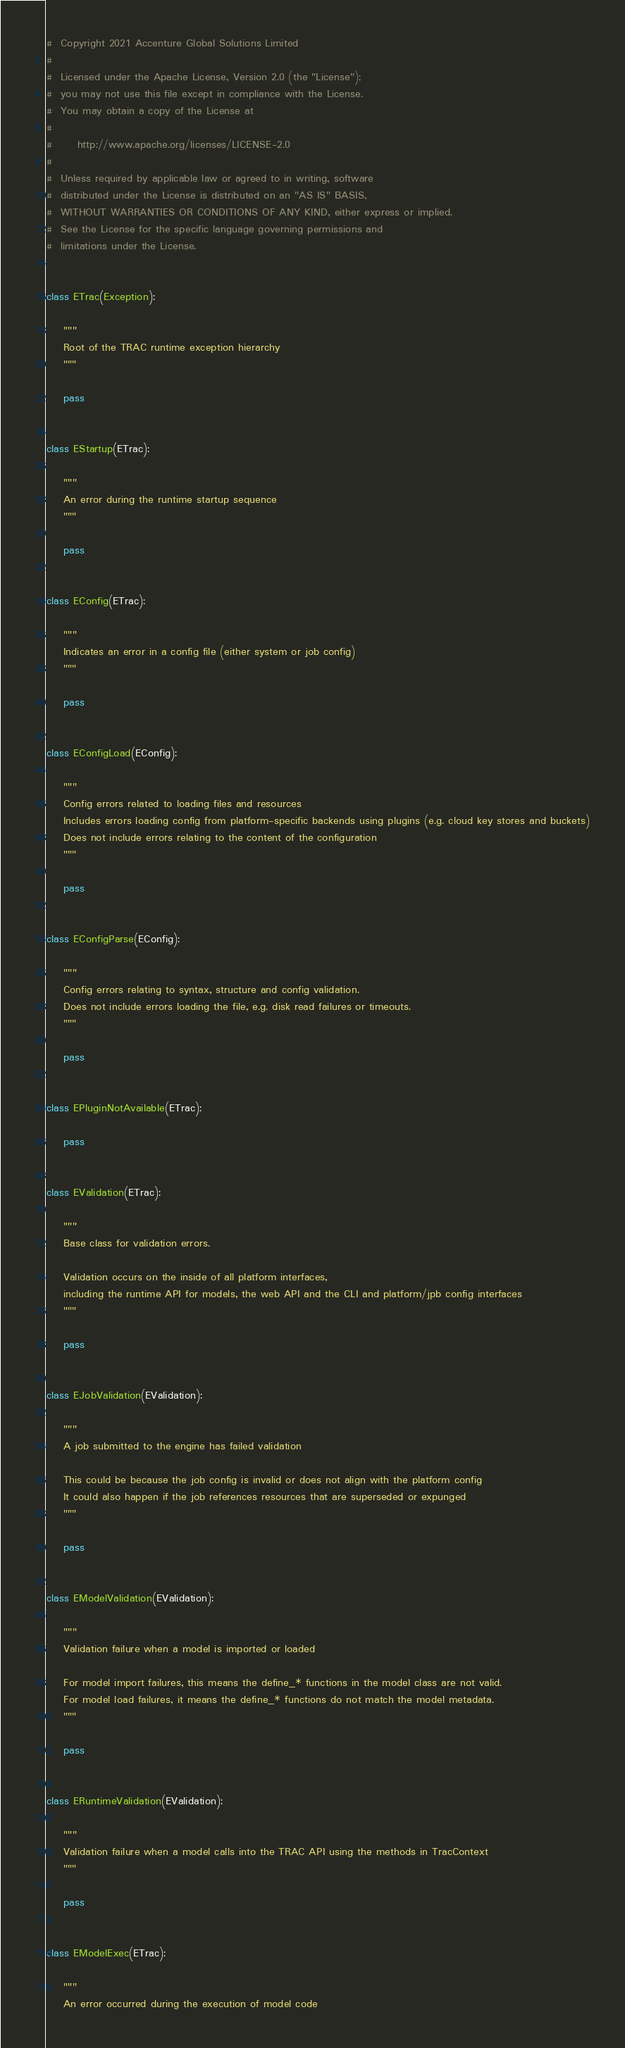<code> <loc_0><loc_0><loc_500><loc_500><_Python_>#  Copyright 2021 Accenture Global Solutions Limited
#
#  Licensed under the Apache License, Version 2.0 (the "License");
#  you may not use this file except in compliance with the License.
#  You may obtain a copy of the License at
#
#      http://www.apache.org/licenses/LICENSE-2.0
#
#  Unless required by applicable law or agreed to in writing, software
#  distributed under the License is distributed on an "AS IS" BASIS,
#  WITHOUT WARRANTIES OR CONDITIONS OF ANY KIND, either express or implied.
#  See the License for the specific language governing permissions and
#  limitations under the License.


class ETrac(Exception):

    """
    Root of the TRAC runtime exception hierarchy
    """

    pass


class EStartup(ETrac):

    """
    An error during the runtime startup sequence
    """

    pass


class EConfig(ETrac):

    """
    Indicates an error in a config file (either system or job config)
    """

    pass


class EConfigLoad(EConfig):

    """
    Config errors related to loading files and resources
    Includes errors loading config from platform-specific backends using plugins (e.g. cloud key stores and buckets)
    Does not include errors relating to the content of the configuration
    """

    pass


class EConfigParse(EConfig):

    """
    Config errors relating to syntax, structure and config validation.
    Does not include errors loading the file, e.g. disk read failures or timeouts.
    """

    pass


class EPluginNotAvailable(ETrac):

    pass


class EValidation(ETrac):

    """
    Base class for validation errors.

    Validation occurs on the inside of all platform interfaces,
    including the runtime API for models, the web API and the CLI and platform/jpb config interfaces
    """

    pass


class EJobValidation(EValidation):

    """
    A job submitted to the engine has failed validation

    This could be because the job config is invalid or does not align with the platform config
    It could also happen if the job references resources that are superseded or expunged
    """

    pass


class EModelValidation(EValidation):

    """
    Validation failure when a model is imported or loaded

    For model import failures, this means the define_* functions in the model class are not valid.
    For model load failures, it means the define_* functions do not match the model metadata.
    """

    pass


class ERuntimeValidation(EValidation):

    """
    Validation failure when a model calls into the TRAC API using the methods in TracContext
    """

    pass


class EModelExec(ETrac):

    """
    An error occurred during the execution of model code
</code> 